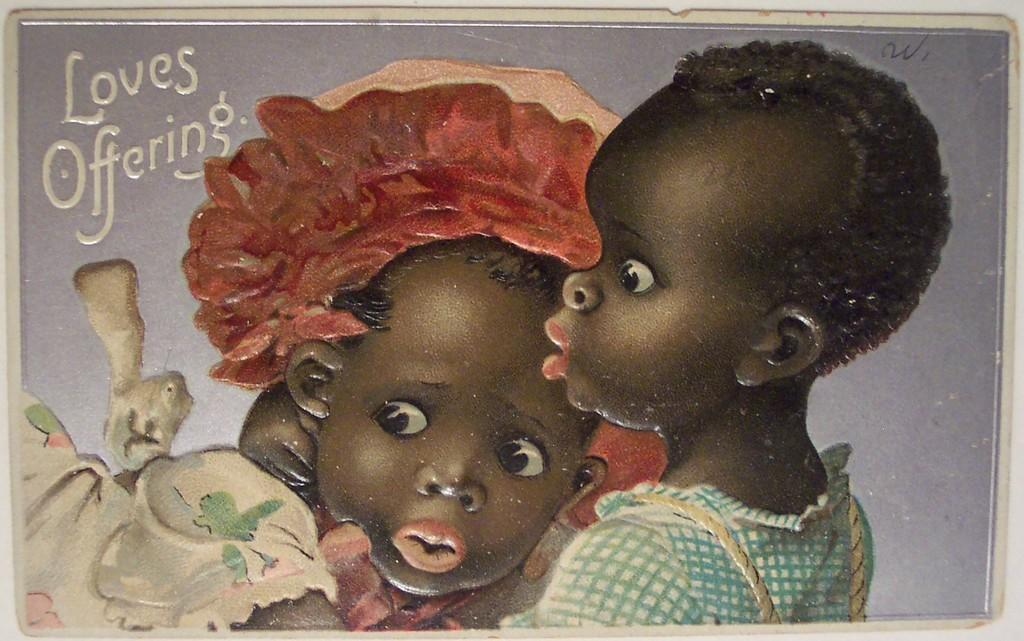What is the main subject of the image? There is a painting in the image. What is depicted in the painting? The painting depicts two kids. Is there any text present in the painting? Yes, there is text written on the painting. What type of volleyball game is being played in the painting? There is no volleyball game present in the painting; it depicts two kids. How many yards are visible in the painting? There is no yard depicted in the painting; it is a painting of two kids. 